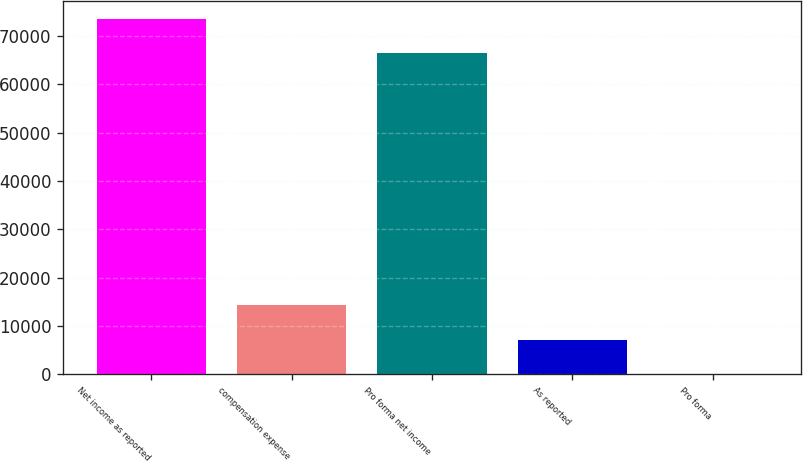<chart> <loc_0><loc_0><loc_500><loc_500><bar_chart><fcel>Net income as reported<fcel>compensation expense<fcel>Pro forma net income<fcel>As reported<fcel>Pro forma<nl><fcel>73652.4<fcel>14319.8<fcel>66493<fcel>7160.36<fcel>0.95<nl></chart> 